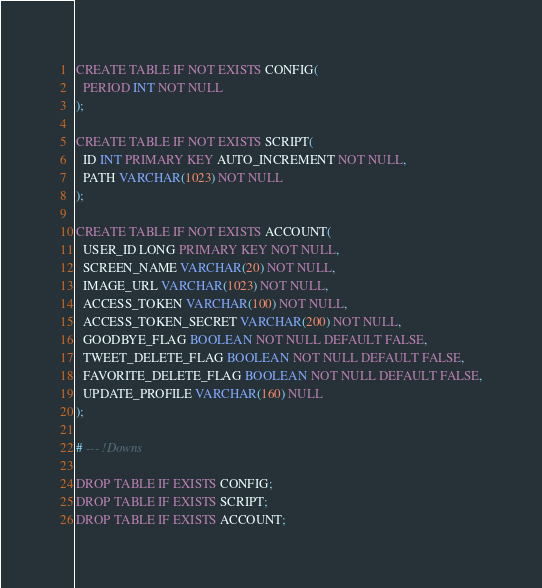Convert code to text. <code><loc_0><loc_0><loc_500><loc_500><_SQL_>CREATE TABLE IF NOT EXISTS CONFIG(
  PERIOD INT NOT NULL
);

CREATE TABLE IF NOT EXISTS SCRIPT(
  ID INT PRIMARY KEY AUTO_INCREMENT NOT NULL,
  PATH VARCHAR(1023) NOT NULL
);

CREATE TABLE IF NOT EXISTS ACCOUNT(
  USER_ID LONG PRIMARY KEY NOT NULL,
  SCREEN_NAME VARCHAR(20) NOT NULL,
  IMAGE_URL VARCHAR(1023) NOT NULL,
  ACCESS_TOKEN VARCHAR(100) NOT NULL,
  ACCESS_TOKEN_SECRET VARCHAR(200) NOT NULL,
  GOODBYE_FLAG BOOLEAN NOT NULL DEFAULT FALSE,
  TWEET_DELETE_FLAG BOOLEAN NOT NULL DEFAULT FALSE,
  FAVORITE_DELETE_FLAG BOOLEAN NOT NULL DEFAULT FALSE,
  UPDATE_PROFILE VARCHAR(160) NULL
);

# --- !Downs

DROP TABLE IF EXISTS CONFIG;
DROP TABLE IF EXISTS SCRIPT;
DROP TABLE IF EXISTS ACCOUNT;
</code> 